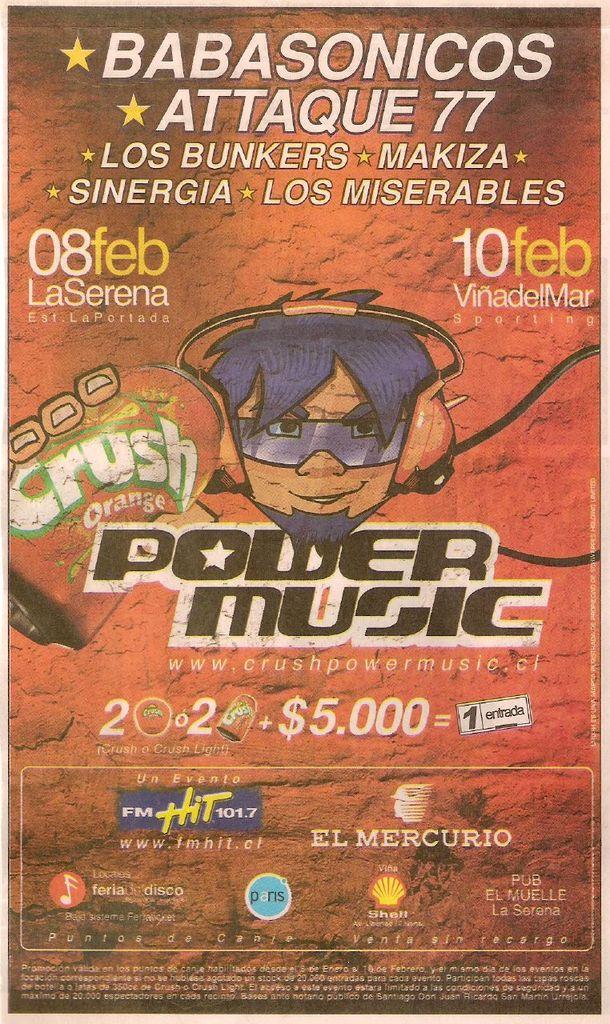When is the event held ?
Offer a very short reply. Feb 08 and feb 10. 